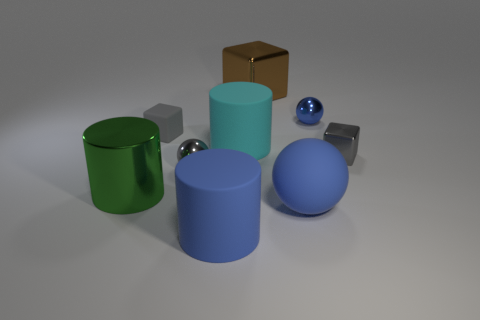What lighting conditions are suggested by the shadows in the image? The shadows indicate a single light source positioned above and possibly slightly to the front of the objects, casting slightly elongated shadows behind and to the right of each object.  What time of day might it be analogous to, considering the length of the shadows if the setting were outdoors? If this were an outdoor setting, the length of the shadows could be indicative of a time either in the early morning or late afternoon, when the sun is at an angle that casts longer shadows. 